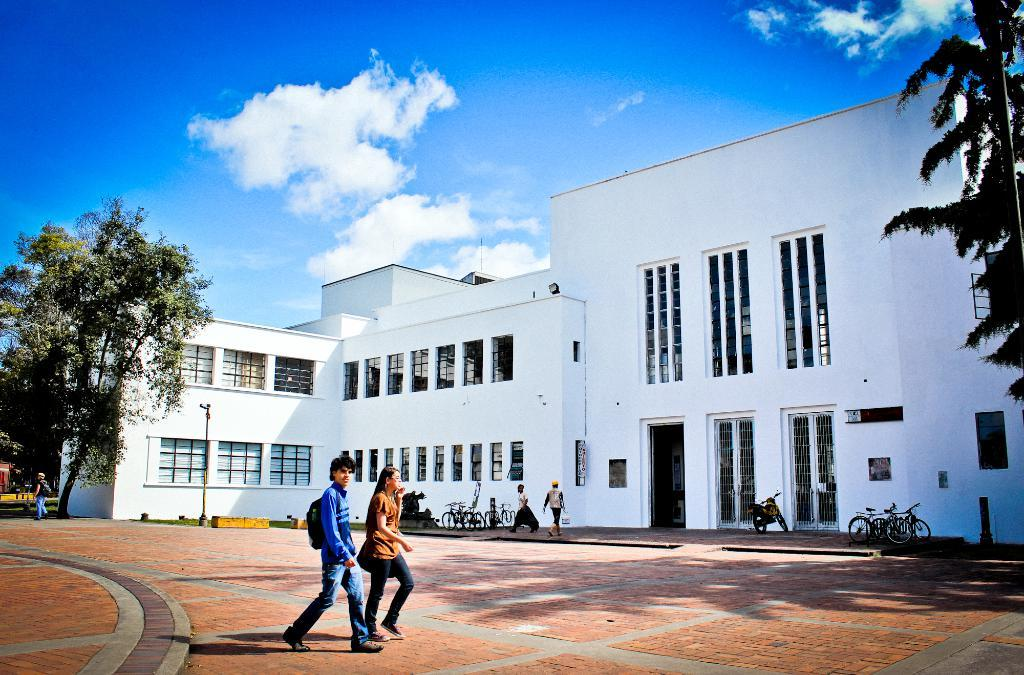What are the people in the image doing? The people in the image are walking in front of a building. Are there any vehicles present in the image? Yes, some vehicles are parked nearby. What can be seen in the background or surroundings of the image? There are trees in the vicinity. What songs are the geese singing in the background? There are no geese present in the image, so there is no singing or any related sounds. 